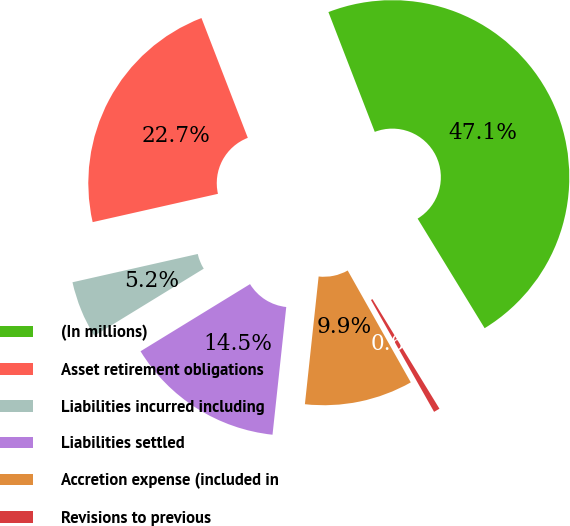<chart> <loc_0><loc_0><loc_500><loc_500><pie_chart><fcel>(In millions)<fcel>Asset retirement obligations<fcel>Liabilities incurred including<fcel>Liabilities settled<fcel>Accretion expense (included in<fcel>Revisions to previous<nl><fcel>47.14%<fcel>22.66%<fcel>5.22%<fcel>14.54%<fcel>9.88%<fcel>0.56%<nl></chart> 